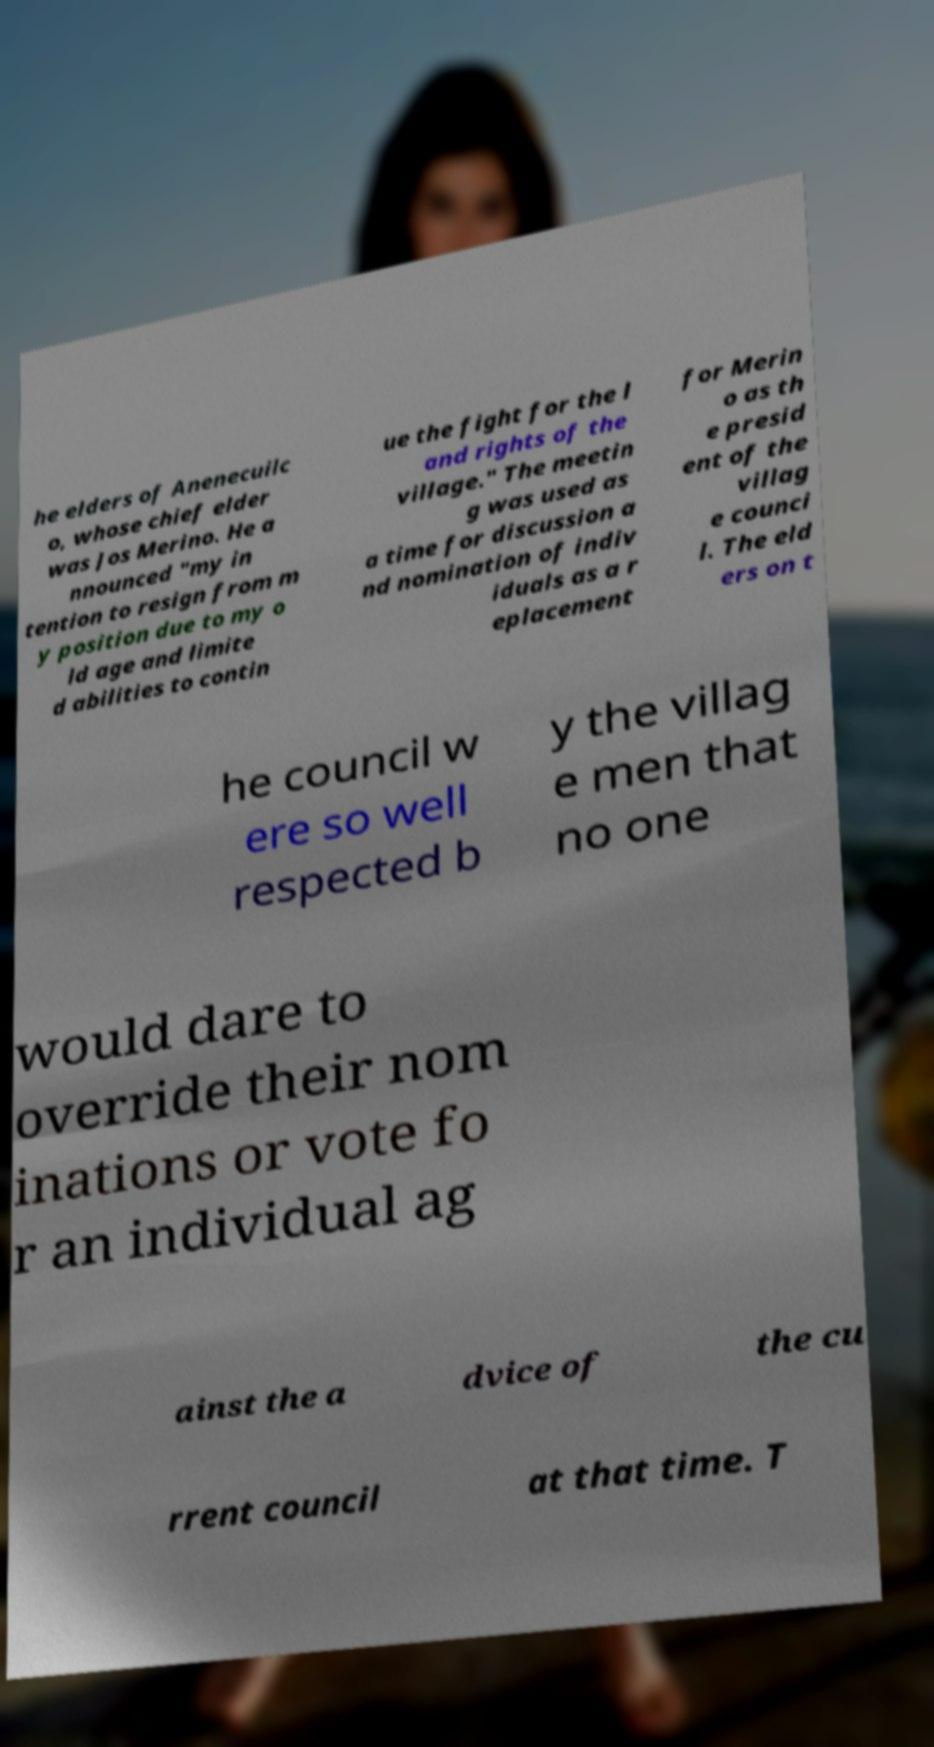Can you accurately transcribe the text from the provided image for me? he elders of Anenecuilc o, whose chief elder was Jos Merino. He a nnounced "my in tention to resign from m y position due to my o ld age and limite d abilities to contin ue the fight for the l and rights of the village." The meetin g was used as a time for discussion a nd nomination of indiv iduals as a r eplacement for Merin o as th e presid ent of the villag e counci l. The eld ers on t he council w ere so well respected b y the villag e men that no one would dare to override their nom inations or vote fo r an individual ag ainst the a dvice of the cu rrent council at that time. T 